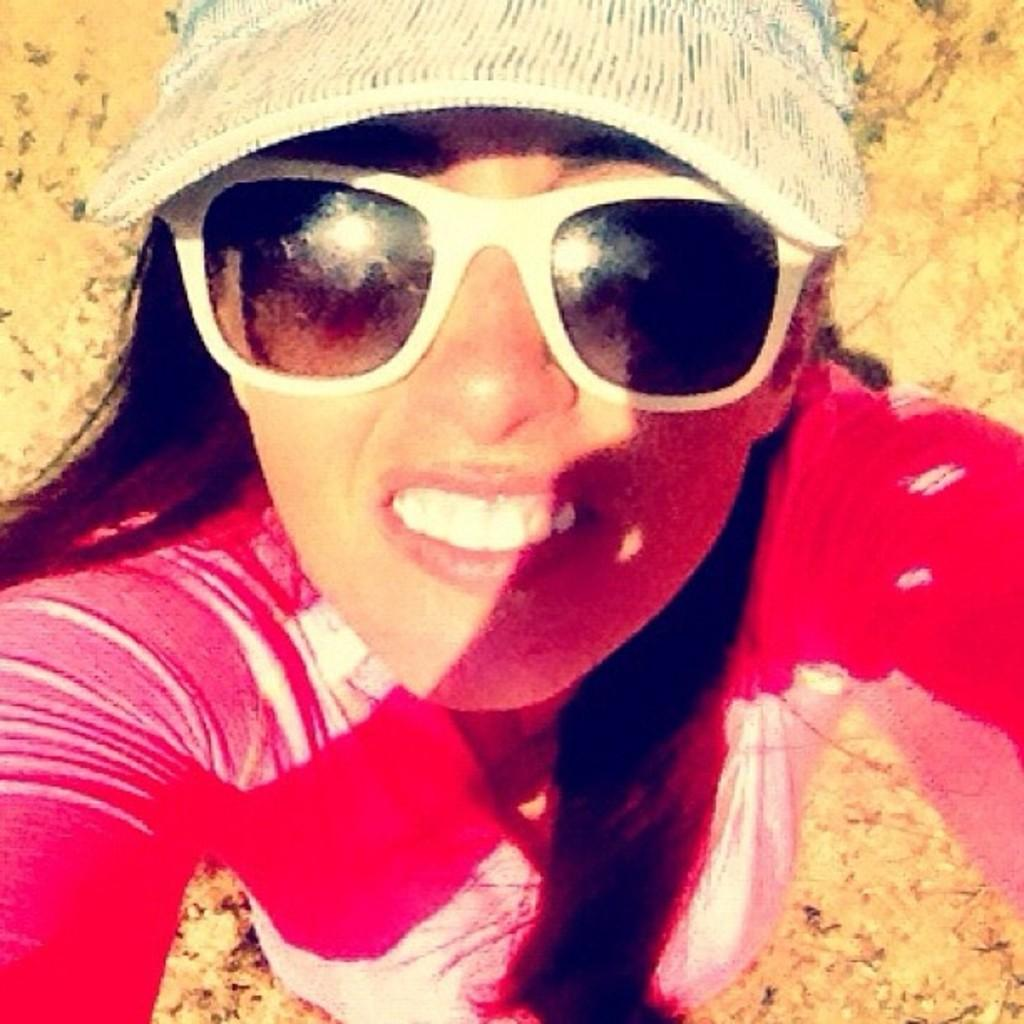Who is the main subject in the image? There is a woman in the image. What is the woman doing in the image? The woman is standing. What accessories is the woman wearing in the image? The woman is wearing glasses and a cap. What is the color of the background in the image? The background of the image is brown. What date is marked on the calendar in the image? There is no calendar present in the image. What type of observation can be made from the hill in the image? There is no hill present in the image. 